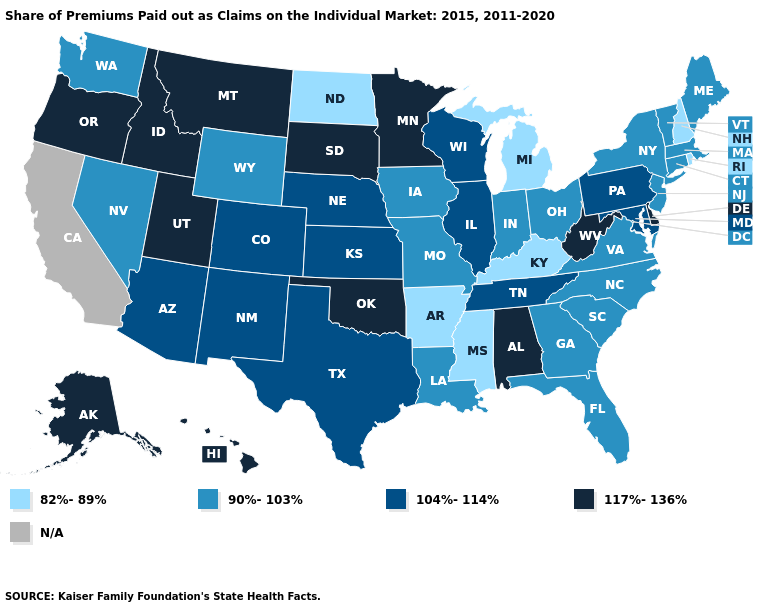What is the lowest value in the USA?
Write a very short answer. 82%-89%. How many symbols are there in the legend?
Answer briefly. 5. Does the first symbol in the legend represent the smallest category?
Quick response, please. Yes. Which states have the lowest value in the USA?
Quick response, please. Arkansas, Kentucky, Michigan, Mississippi, New Hampshire, North Dakota, Rhode Island. Name the states that have a value in the range N/A?
Quick response, please. California. Does Mississippi have the lowest value in the USA?
Concise answer only. Yes. Which states have the lowest value in the Northeast?
Write a very short answer. New Hampshire, Rhode Island. Which states have the lowest value in the USA?
Keep it brief. Arkansas, Kentucky, Michigan, Mississippi, New Hampshire, North Dakota, Rhode Island. Among the states that border Rhode Island , which have the lowest value?
Short answer required. Connecticut, Massachusetts. How many symbols are there in the legend?
Answer briefly. 5. Name the states that have a value in the range 104%-114%?
Answer briefly. Arizona, Colorado, Illinois, Kansas, Maryland, Nebraska, New Mexico, Pennsylvania, Tennessee, Texas, Wisconsin. What is the highest value in the West ?
Give a very brief answer. 117%-136%. What is the highest value in the MidWest ?
Give a very brief answer. 117%-136%. Name the states that have a value in the range 82%-89%?
Write a very short answer. Arkansas, Kentucky, Michigan, Mississippi, New Hampshire, North Dakota, Rhode Island. 